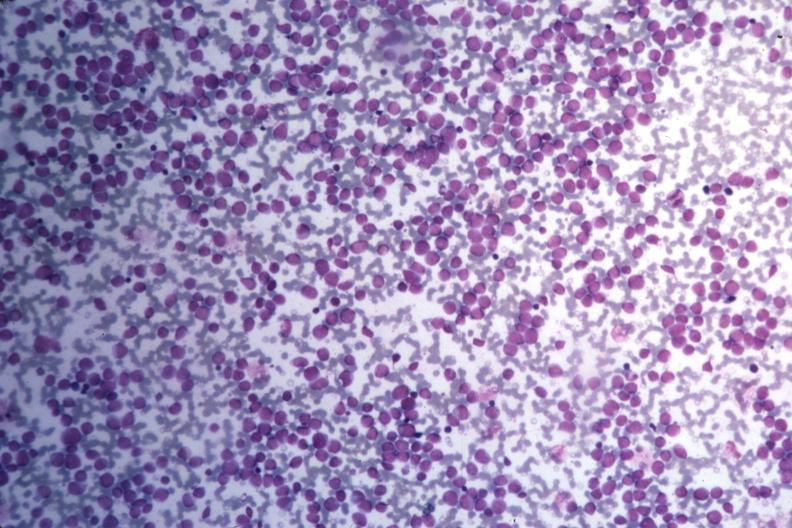s hemorrhage newborn present?
Answer the question using a single word or phrase. No 